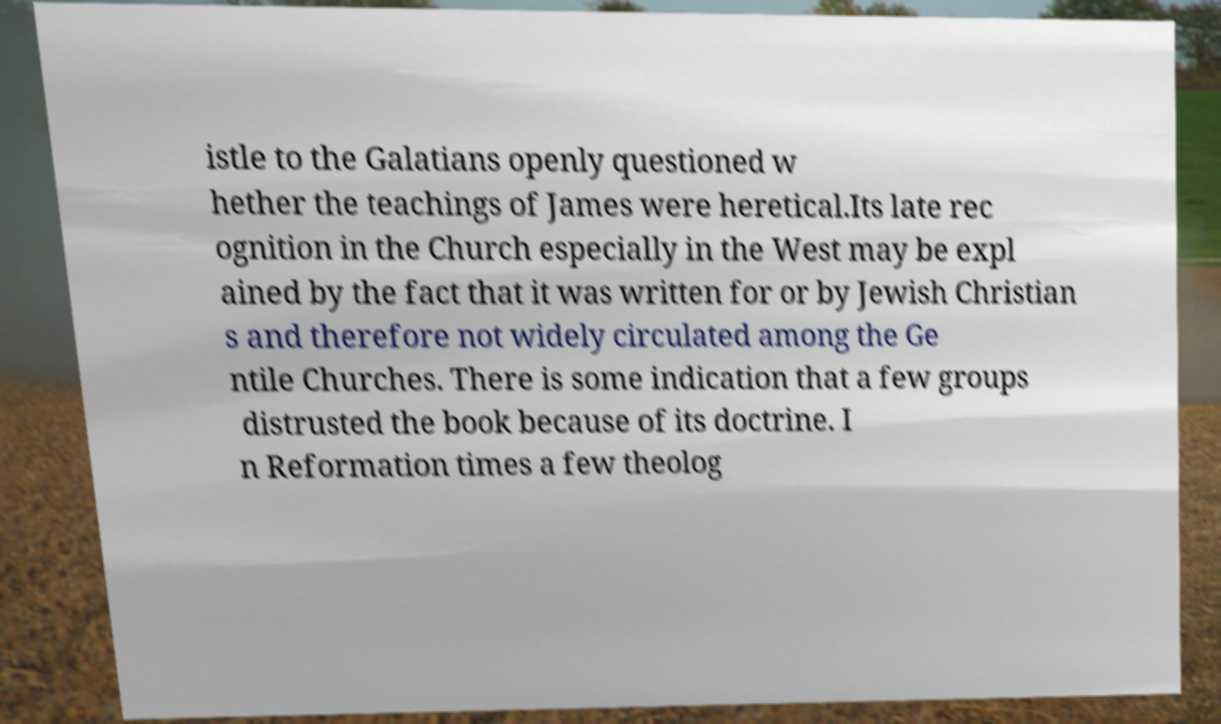There's text embedded in this image that I need extracted. Can you transcribe it verbatim? istle to the Galatians openly questioned w hether the teachings of James were heretical.Its late rec ognition in the Church especially in the West may be expl ained by the fact that it was written for or by Jewish Christian s and therefore not widely circulated among the Ge ntile Churches. There is some indication that a few groups distrusted the book because of its doctrine. I n Reformation times a few theolog 